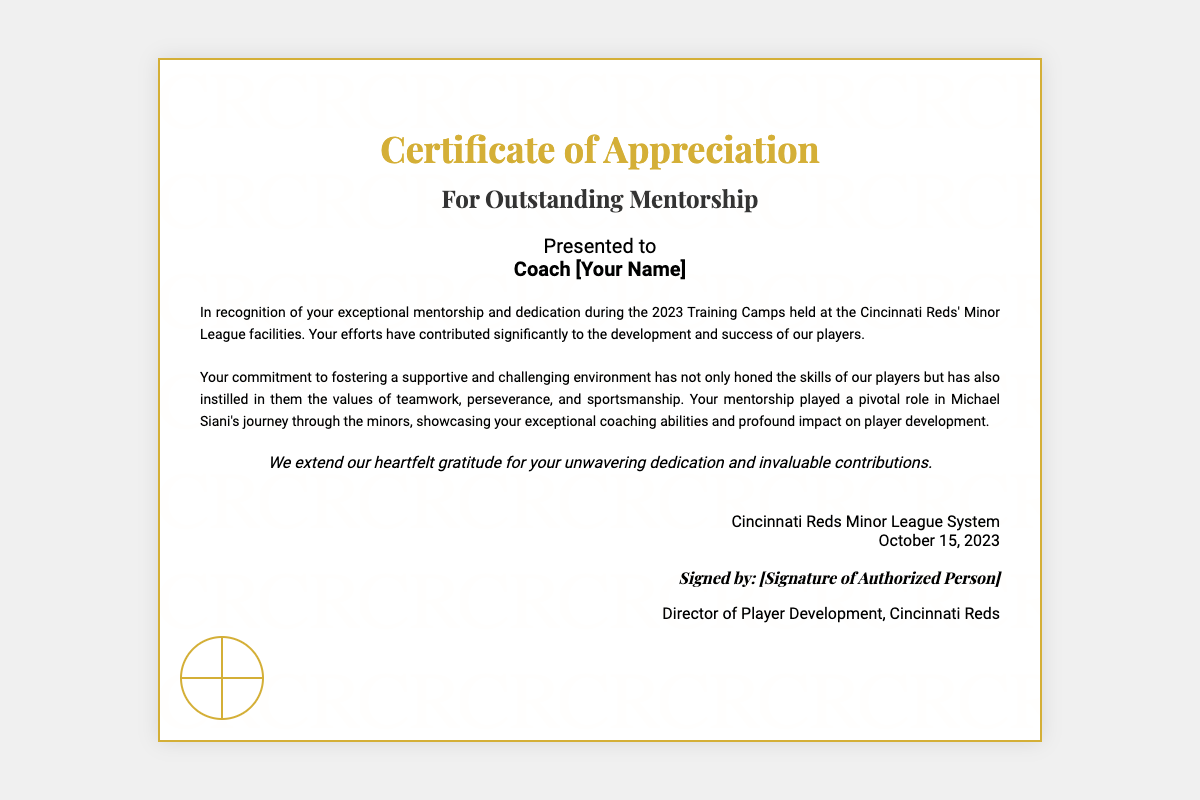What is the title of the certificate? The title of the certificate is prominently displayed at the top of the document, stating the purpose of the award.
Answer: Certificate of Appreciation Who is the certificate presented to? The recipient's name is specified under the "Presented to" section, indicating who receives the acknowledgment.
Answer: Coach [Your Name] What is the date on the certificate? The date is found in the issuer section, providing the official awarding date of the certificate.
Answer: October 15, 2023 Which organization issued the certificate? The issuer of the certificate is listed at the bottom, identifying the authority granting the certificate.
Answer: Cincinnati Reds Minor League System What is noted as a key quality of the mentorship? The testimonial section highlights significant aspects of the individual's contributions in mentoring the players.
Answer: Exceptional mentorship Who played a pivotal role in Michael Siani's development? The testimonial specifically mentions the impact of the selected coach on Michael Siani’s progress in the minors.
Answer: Coach [Your Name] What is the closing remark of the certificate? The closing statement expresses gratitude, giving a final acknowledgment of the recipient's contributions.
Answer: Heartfelt gratitude What is the role of the person who signs the certificate? The signatory's position is mentioned under the signature section, describing their authority in relation to the certificate.
Answer: Director of Player Development 